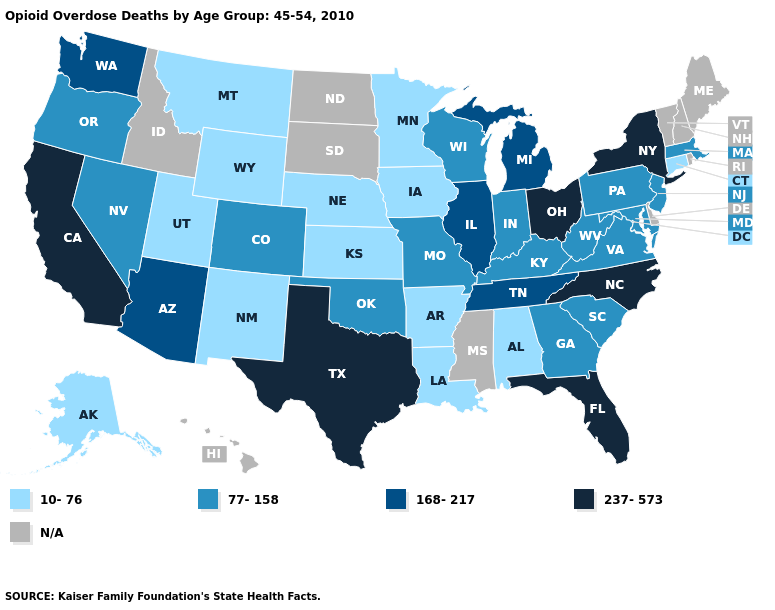Does Virginia have the highest value in the South?
Short answer required. No. What is the lowest value in the West?
Keep it brief. 10-76. What is the value of Maryland?
Write a very short answer. 77-158. What is the value of Hawaii?
Write a very short answer. N/A. What is the value of South Dakota?
Write a very short answer. N/A. Name the states that have a value in the range 237-573?
Short answer required. California, Florida, New York, North Carolina, Ohio, Texas. What is the value of Maryland?
Quick response, please. 77-158. Does Florida have the highest value in the USA?
Give a very brief answer. Yes. What is the value of Arizona?
Short answer required. 168-217. What is the value of North Dakota?
Write a very short answer. N/A. Name the states that have a value in the range N/A?
Write a very short answer. Delaware, Hawaii, Idaho, Maine, Mississippi, New Hampshire, North Dakota, Rhode Island, South Dakota, Vermont. What is the highest value in states that border Mississippi?
Be succinct. 168-217. 